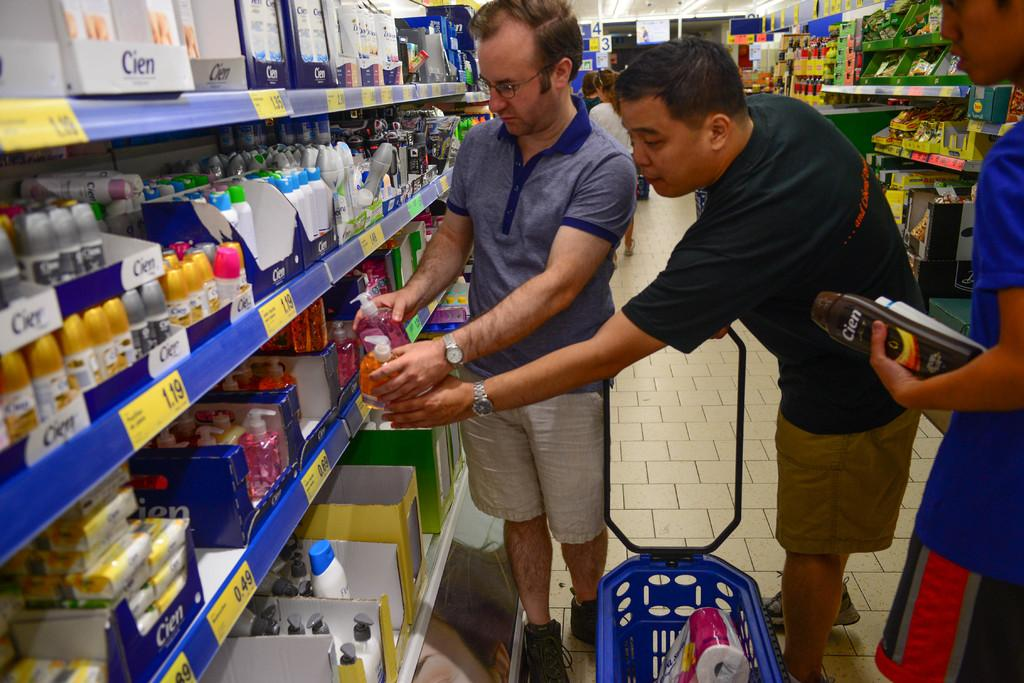What is the gender of the people in the image? There are men in the image. Where are the men positioned in the image? The men are standing on the floor. What are the men holding in their hands? The men are holding soap liquid bottles in their hands. What type of ink is being used by the men in the image? There is no ink present in the image; the men are holding soap liquid bottles. 